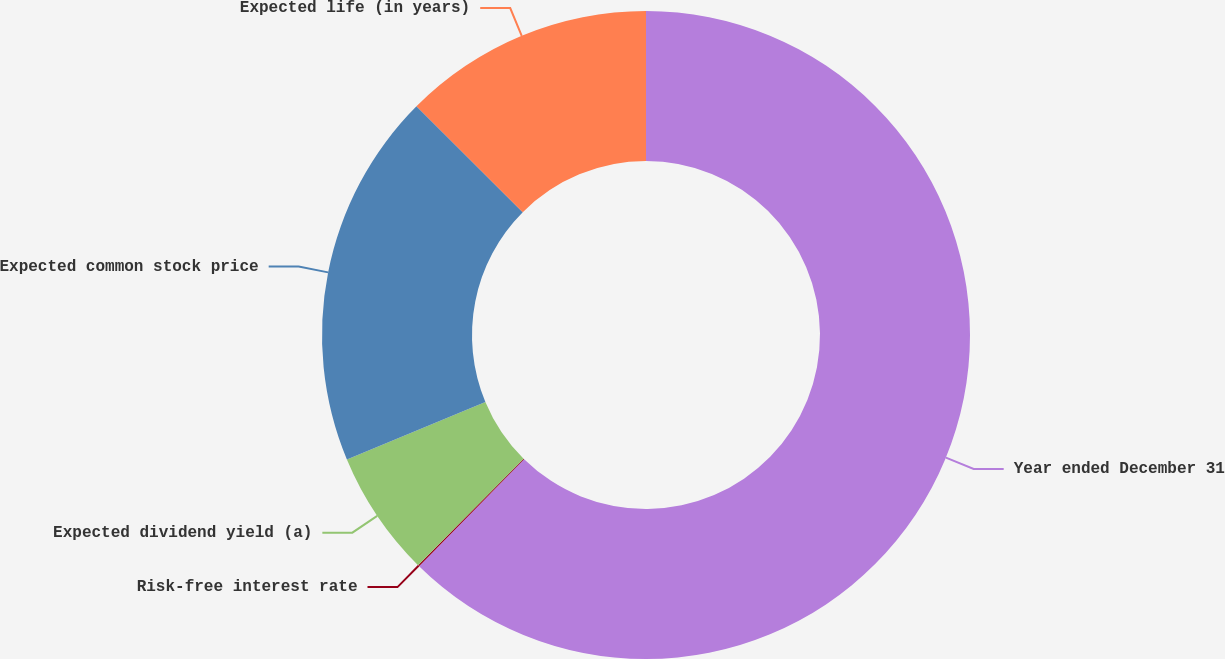Convert chart to OTSL. <chart><loc_0><loc_0><loc_500><loc_500><pie_chart><fcel>Year ended December 31<fcel>Risk-free interest rate<fcel>Expected dividend yield (a)<fcel>Expected common stock price<fcel>Expected life (in years)<nl><fcel>62.35%<fcel>0.07%<fcel>6.3%<fcel>18.75%<fcel>12.53%<nl></chart> 